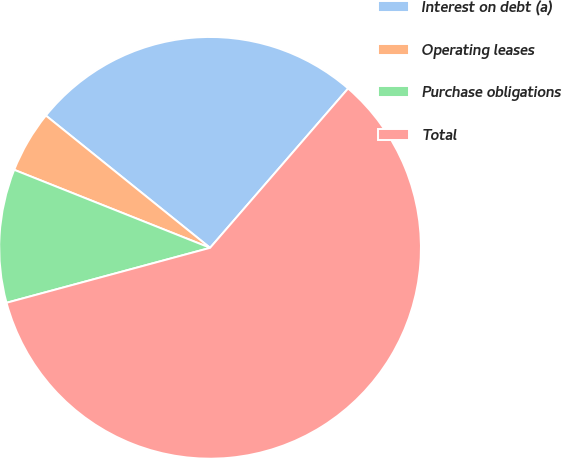Convert chart. <chart><loc_0><loc_0><loc_500><loc_500><pie_chart><fcel>Interest on debt (a)<fcel>Operating leases<fcel>Purchase obligations<fcel>Total<nl><fcel>25.57%<fcel>4.76%<fcel>10.23%<fcel>59.45%<nl></chart> 